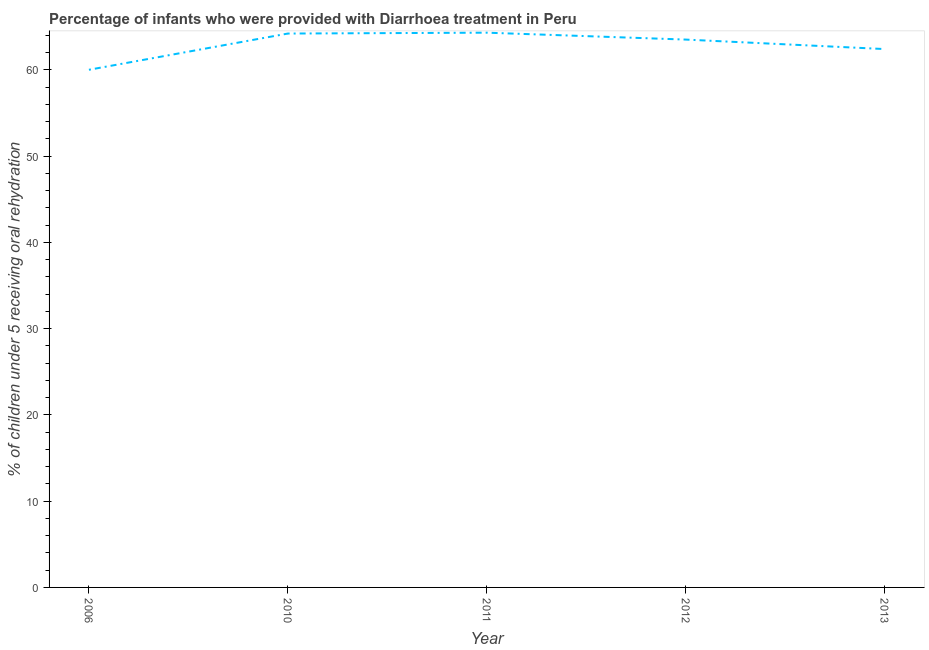What is the percentage of children who were provided with treatment diarrhoea in 2011?
Offer a terse response. 64.3. Across all years, what is the maximum percentage of children who were provided with treatment diarrhoea?
Offer a terse response. 64.3. Across all years, what is the minimum percentage of children who were provided with treatment diarrhoea?
Provide a succinct answer. 60. In which year was the percentage of children who were provided with treatment diarrhoea minimum?
Make the answer very short. 2006. What is the sum of the percentage of children who were provided with treatment diarrhoea?
Your answer should be compact. 314.4. What is the difference between the percentage of children who were provided with treatment diarrhoea in 2006 and 2013?
Your answer should be very brief. -2.4. What is the average percentage of children who were provided with treatment diarrhoea per year?
Your response must be concise. 62.88. What is the median percentage of children who were provided with treatment diarrhoea?
Offer a terse response. 63.5. In how many years, is the percentage of children who were provided with treatment diarrhoea greater than 32 %?
Your answer should be compact. 5. What is the ratio of the percentage of children who were provided with treatment diarrhoea in 2010 to that in 2012?
Give a very brief answer. 1.01. Is the percentage of children who were provided with treatment diarrhoea in 2012 less than that in 2013?
Your response must be concise. No. What is the difference between the highest and the second highest percentage of children who were provided with treatment diarrhoea?
Make the answer very short. 0.1. Is the sum of the percentage of children who were provided with treatment diarrhoea in 2010 and 2013 greater than the maximum percentage of children who were provided with treatment diarrhoea across all years?
Your answer should be compact. Yes. What is the difference between the highest and the lowest percentage of children who were provided with treatment diarrhoea?
Make the answer very short. 4.3. How many lines are there?
Make the answer very short. 1. How many years are there in the graph?
Keep it short and to the point. 5. Does the graph contain any zero values?
Your answer should be compact. No. What is the title of the graph?
Offer a very short reply. Percentage of infants who were provided with Diarrhoea treatment in Peru. What is the label or title of the Y-axis?
Your response must be concise. % of children under 5 receiving oral rehydration. What is the % of children under 5 receiving oral rehydration in 2006?
Make the answer very short. 60. What is the % of children under 5 receiving oral rehydration in 2010?
Your answer should be very brief. 64.2. What is the % of children under 5 receiving oral rehydration of 2011?
Your answer should be very brief. 64.3. What is the % of children under 5 receiving oral rehydration in 2012?
Your response must be concise. 63.5. What is the % of children under 5 receiving oral rehydration of 2013?
Your answer should be compact. 62.4. What is the difference between the % of children under 5 receiving oral rehydration in 2006 and 2013?
Ensure brevity in your answer.  -2.4. What is the difference between the % of children under 5 receiving oral rehydration in 2010 and 2012?
Offer a terse response. 0.7. What is the difference between the % of children under 5 receiving oral rehydration in 2010 and 2013?
Offer a very short reply. 1.8. What is the difference between the % of children under 5 receiving oral rehydration in 2011 and 2012?
Offer a terse response. 0.8. What is the difference between the % of children under 5 receiving oral rehydration in 2012 and 2013?
Offer a very short reply. 1.1. What is the ratio of the % of children under 5 receiving oral rehydration in 2006 to that in 2010?
Your answer should be very brief. 0.94. What is the ratio of the % of children under 5 receiving oral rehydration in 2006 to that in 2011?
Keep it short and to the point. 0.93. What is the ratio of the % of children under 5 receiving oral rehydration in 2006 to that in 2012?
Your answer should be very brief. 0.94. What is the ratio of the % of children under 5 receiving oral rehydration in 2010 to that in 2011?
Give a very brief answer. 1. What is the ratio of the % of children under 5 receiving oral rehydration in 2010 to that in 2012?
Provide a short and direct response. 1.01. What is the ratio of the % of children under 5 receiving oral rehydration in 2010 to that in 2013?
Offer a very short reply. 1.03. What is the ratio of the % of children under 5 receiving oral rehydration in 2011 to that in 2013?
Keep it short and to the point. 1.03. What is the ratio of the % of children under 5 receiving oral rehydration in 2012 to that in 2013?
Offer a terse response. 1.02. 